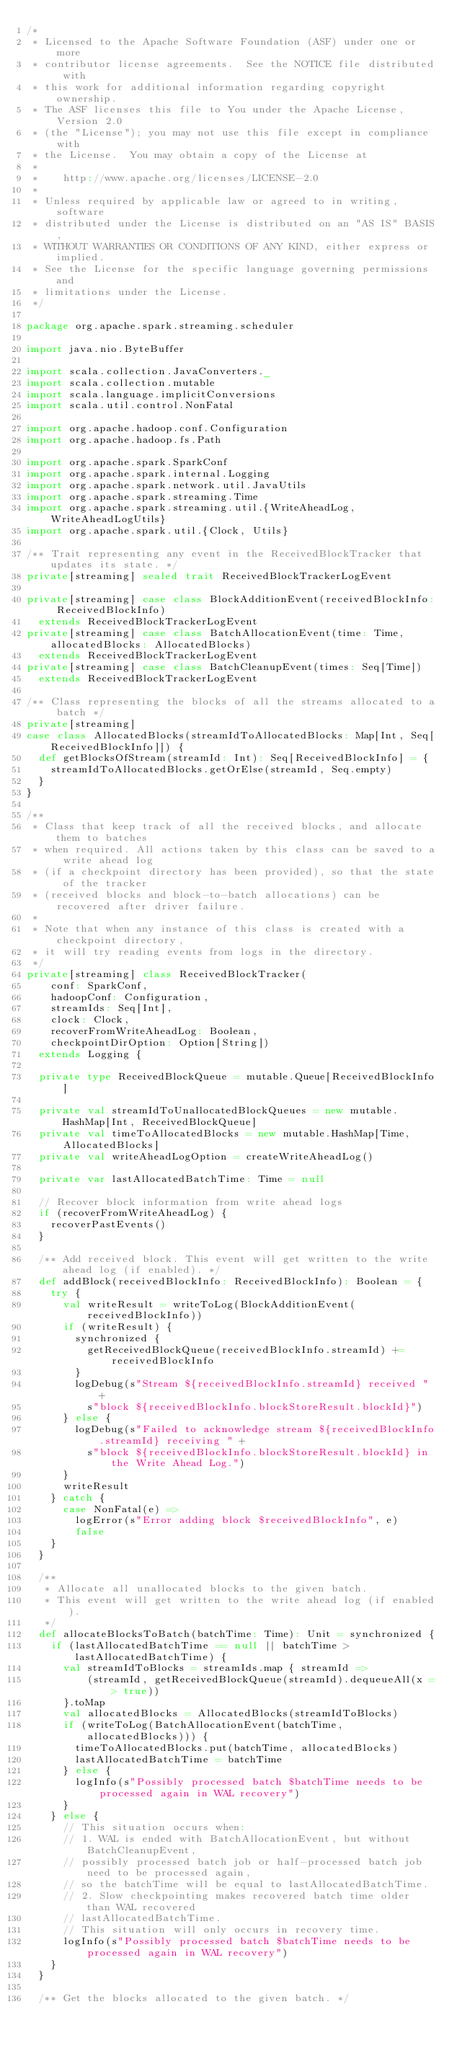<code> <loc_0><loc_0><loc_500><loc_500><_Scala_>/*
 * Licensed to the Apache Software Foundation (ASF) under one or more
 * contributor license agreements.  See the NOTICE file distributed with
 * this work for additional information regarding copyright ownership.
 * The ASF licenses this file to You under the Apache License, Version 2.0
 * (the "License"); you may not use this file except in compliance with
 * the License.  You may obtain a copy of the License at
 *
 *    http://www.apache.org/licenses/LICENSE-2.0
 *
 * Unless required by applicable law or agreed to in writing, software
 * distributed under the License is distributed on an "AS IS" BASIS,
 * WITHOUT WARRANTIES OR CONDITIONS OF ANY KIND, either express or implied.
 * See the License for the specific language governing permissions and
 * limitations under the License.
 */

package org.apache.spark.streaming.scheduler

import java.nio.ByteBuffer

import scala.collection.JavaConverters._
import scala.collection.mutable
import scala.language.implicitConversions
import scala.util.control.NonFatal

import org.apache.hadoop.conf.Configuration
import org.apache.hadoop.fs.Path

import org.apache.spark.SparkConf
import org.apache.spark.internal.Logging
import org.apache.spark.network.util.JavaUtils
import org.apache.spark.streaming.Time
import org.apache.spark.streaming.util.{WriteAheadLog, WriteAheadLogUtils}
import org.apache.spark.util.{Clock, Utils}

/** Trait representing any event in the ReceivedBlockTracker that updates its state. */
private[streaming] sealed trait ReceivedBlockTrackerLogEvent

private[streaming] case class BlockAdditionEvent(receivedBlockInfo: ReceivedBlockInfo)
  extends ReceivedBlockTrackerLogEvent
private[streaming] case class BatchAllocationEvent(time: Time, allocatedBlocks: AllocatedBlocks)
  extends ReceivedBlockTrackerLogEvent
private[streaming] case class BatchCleanupEvent(times: Seq[Time])
  extends ReceivedBlockTrackerLogEvent

/** Class representing the blocks of all the streams allocated to a batch */
private[streaming]
case class AllocatedBlocks(streamIdToAllocatedBlocks: Map[Int, Seq[ReceivedBlockInfo]]) {
  def getBlocksOfStream(streamId: Int): Seq[ReceivedBlockInfo] = {
    streamIdToAllocatedBlocks.getOrElse(streamId, Seq.empty)
  }
}

/**
 * Class that keep track of all the received blocks, and allocate them to batches
 * when required. All actions taken by this class can be saved to a write ahead log
 * (if a checkpoint directory has been provided), so that the state of the tracker
 * (received blocks and block-to-batch allocations) can be recovered after driver failure.
 *
 * Note that when any instance of this class is created with a checkpoint directory,
 * it will try reading events from logs in the directory.
 */
private[streaming] class ReceivedBlockTracker(
    conf: SparkConf,
    hadoopConf: Configuration,
    streamIds: Seq[Int],
    clock: Clock,
    recoverFromWriteAheadLog: Boolean,
    checkpointDirOption: Option[String])
  extends Logging {

  private type ReceivedBlockQueue = mutable.Queue[ReceivedBlockInfo]

  private val streamIdToUnallocatedBlockQueues = new mutable.HashMap[Int, ReceivedBlockQueue]
  private val timeToAllocatedBlocks = new mutable.HashMap[Time, AllocatedBlocks]
  private val writeAheadLogOption = createWriteAheadLog()

  private var lastAllocatedBatchTime: Time = null

  // Recover block information from write ahead logs
  if (recoverFromWriteAheadLog) {
    recoverPastEvents()
  }

  /** Add received block. This event will get written to the write ahead log (if enabled). */
  def addBlock(receivedBlockInfo: ReceivedBlockInfo): Boolean = {
    try {
      val writeResult = writeToLog(BlockAdditionEvent(receivedBlockInfo))
      if (writeResult) {
        synchronized {
          getReceivedBlockQueue(receivedBlockInfo.streamId) += receivedBlockInfo
        }
        logDebug(s"Stream ${receivedBlockInfo.streamId} received " +
          s"block ${receivedBlockInfo.blockStoreResult.blockId}")
      } else {
        logDebug(s"Failed to acknowledge stream ${receivedBlockInfo.streamId} receiving " +
          s"block ${receivedBlockInfo.blockStoreResult.blockId} in the Write Ahead Log.")
      }
      writeResult
    } catch {
      case NonFatal(e) =>
        logError(s"Error adding block $receivedBlockInfo", e)
        false
    }
  }

  /**
   * Allocate all unallocated blocks to the given batch.
   * This event will get written to the write ahead log (if enabled).
   */
  def allocateBlocksToBatch(batchTime: Time): Unit = synchronized {
    if (lastAllocatedBatchTime == null || batchTime > lastAllocatedBatchTime) {
      val streamIdToBlocks = streamIds.map { streamId =>
          (streamId, getReceivedBlockQueue(streamId).dequeueAll(x => true))
      }.toMap
      val allocatedBlocks = AllocatedBlocks(streamIdToBlocks)
      if (writeToLog(BatchAllocationEvent(batchTime, allocatedBlocks))) {
        timeToAllocatedBlocks.put(batchTime, allocatedBlocks)
        lastAllocatedBatchTime = batchTime
      } else {
        logInfo(s"Possibly processed batch $batchTime needs to be processed again in WAL recovery")
      }
    } else {
      // This situation occurs when:
      // 1. WAL is ended with BatchAllocationEvent, but without BatchCleanupEvent,
      // possibly processed batch job or half-processed batch job need to be processed again,
      // so the batchTime will be equal to lastAllocatedBatchTime.
      // 2. Slow checkpointing makes recovered batch time older than WAL recovered
      // lastAllocatedBatchTime.
      // This situation will only occurs in recovery time.
      logInfo(s"Possibly processed batch $batchTime needs to be processed again in WAL recovery")
    }
  }

  /** Get the blocks allocated to the given batch. */</code> 